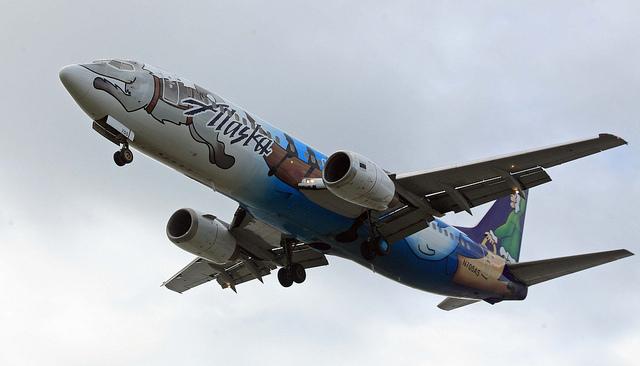Is this a twin engine plane?
Answer briefly. Yes. Are the fighter jets for the navy?
Be succinct. No. Is this a passenger plane?
Keep it brief. Yes. Who is flying the plane?
Write a very short answer. Pilot. What color is the sky?
Be succinct. Gray. What state name is written on the airplane?
Concise answer only. Alaska. What main color is the plane?
Short answer required. White. 